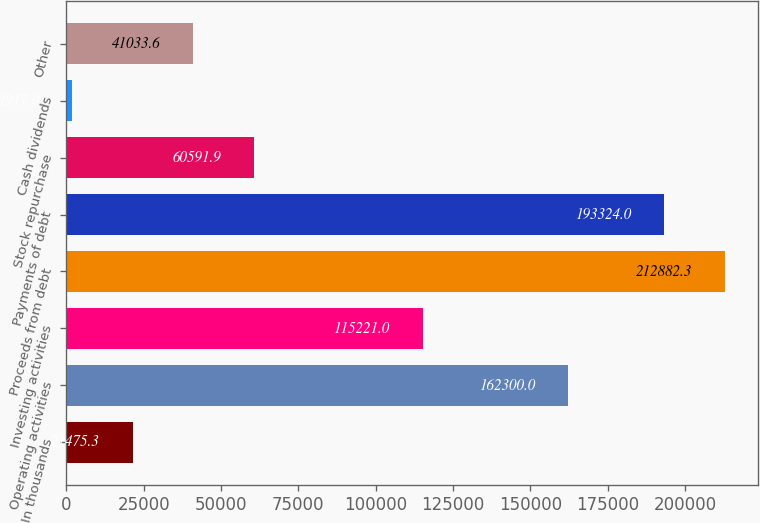<chart> <loc_0><loc_0><loc_500><loc_500><bar_chart><fcel>In thousands<fcel>Operating activities<fcel>Investing activities<fcel>Proceeds from debt<fcel>Payments of debt<fcel>Stock repurchase<fcel>Cash dividends<fcel>Other<nl><fcel>21475.3<fcel>162300<fcel>115221<fcel>212882<fcel>193324<fcel>60591.9<fcel>1917<fcel>41033.6<nl></chart> 